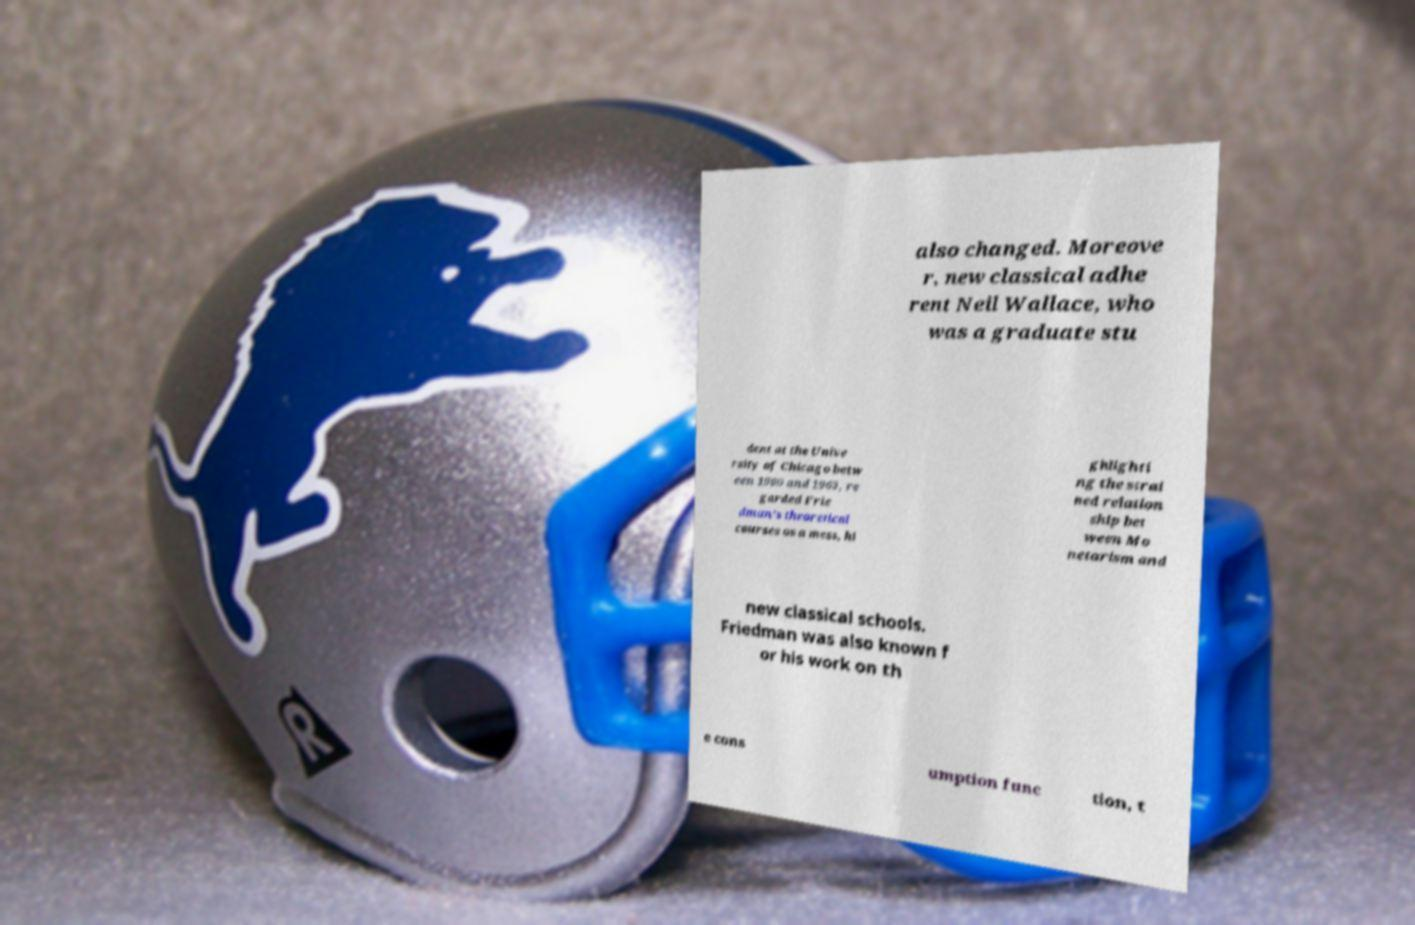What messages or text are displayed in this image? I need them in a readable, typed format. also changed. Moreove r, new classical adhe rent Neil Wallace, who was a graduate stu dent at the Unive rsity of Chicago betw een 1960 and 1963, re garded Frie dman's theoretical courses as a mess, hi ghlighti ng the strai ned relation ship bet ween Mo netarism and new classical schools. Friedman was also known f or his work on th e cons umption func tion, t 